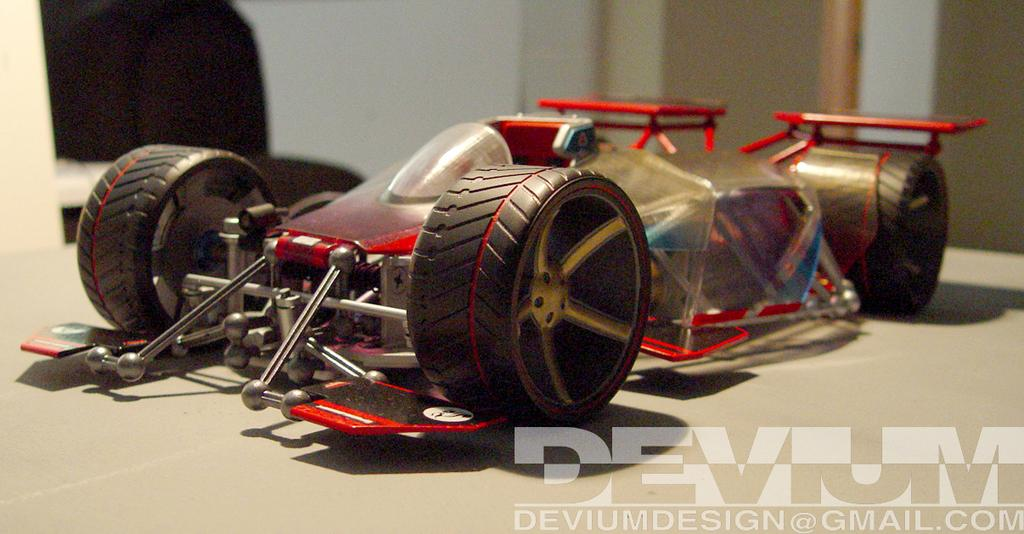What is the main object in the image? There is a toy car in the image. Where is the toy car located? The toy car is on a table surface. How many passengers are in the toy car in the image? There are no passengers in the toy car, as it is a toy and not a real vehicle. 